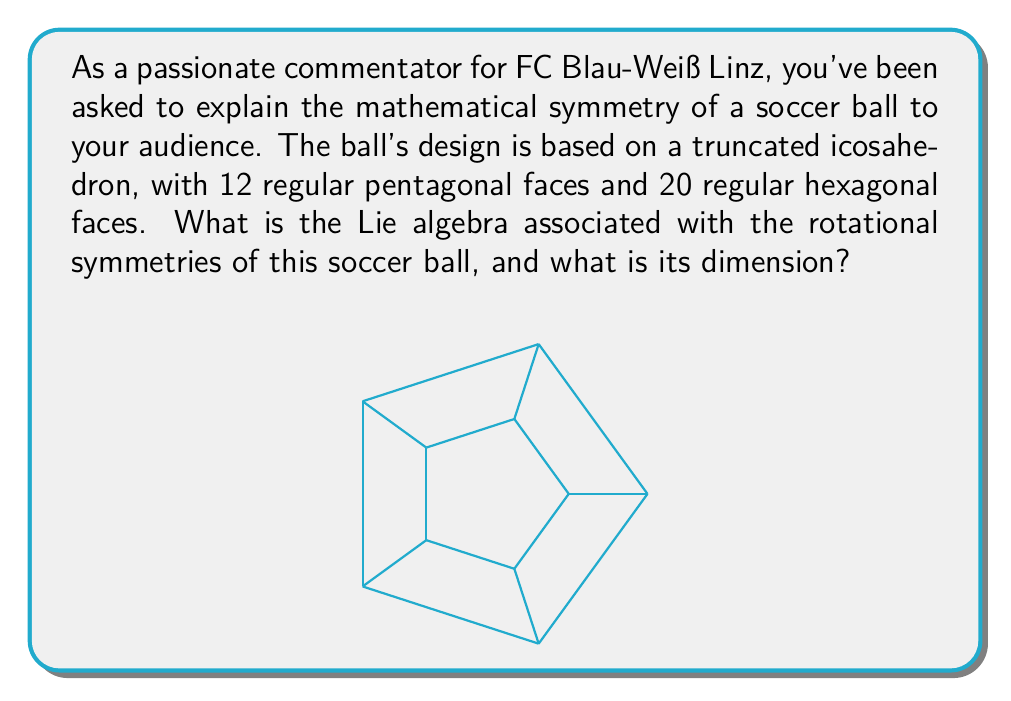Help me with this question. Let's approach this step-by-step:

1) The soccer ball's shape is based on a truncated icosahedron, which belongs to the icosahedral symmetry group.

2) The icosahedral group is isomorphic to the alternating group $A_5$, which has 60 rotational symmetries.

3) These rotational symmetries form a subgroup of $SO(3)$, the special orthogonal group in three dimensions.

4) The Lie algebra associated with $SO(3)$ is $\mathfrak{so}(3)$, which consists of $3 \times 3$ skew-symmetric matrices.

5) A general element of $\mathfrak{so}(3)$ has the form:

   $$
   \begin{pmatrix}
   0 & -\omega_3 & \omega_2 \\
   \omega_3 & 0 & -\omega_1 \\
   -\omega_2 & \omega_1 & 0
   \end{pmatrix}
   $$

6) This matrix is determined by three parameters $(\omega_1, \omega_2, \omega_3)$, which correspond to rotations around the x, y, and z axes respectively.

7) Therefore, the dimension of $\mathfrak{so}(3)$ is 3.

8) The Lie algebra associated with the rotational symmetries of the soccer ball is the same as $\mathfrak{so}(3)$, as it describes all possible infinitesimal rotations in 3D space.

Thus, the Lie algebra associated with the rotational symmetries of the soccer ball is $\mathfrak{so}(3)$, and its dimension is 3.
Answer: $\mathfrak{so}(3)$, dimension 3 